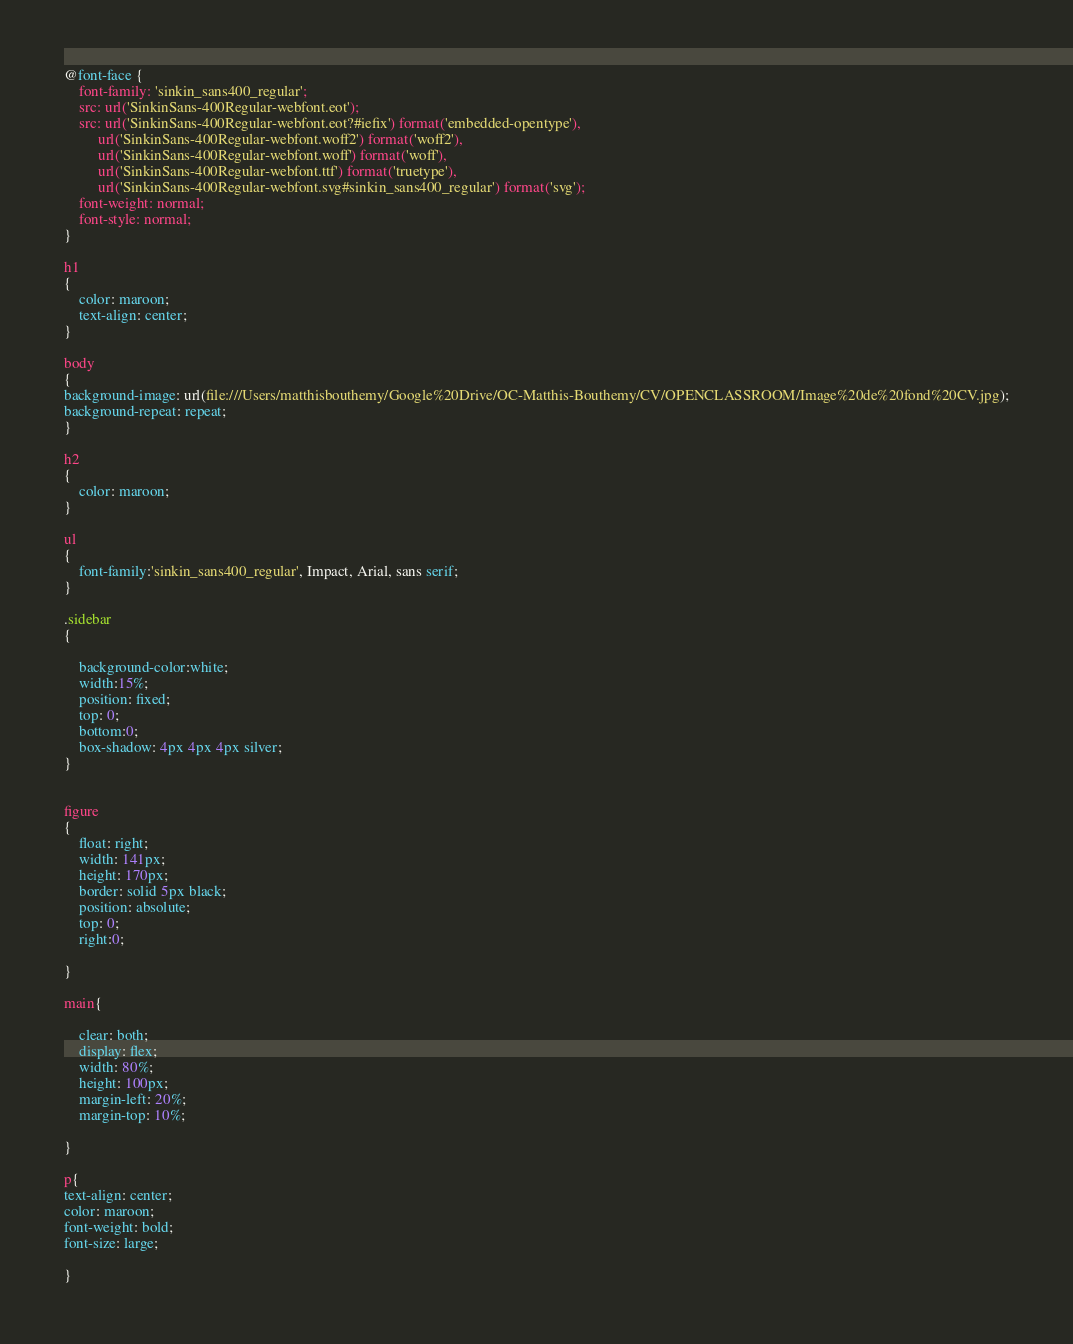<code> <loc_0><loc_0><loc_500><loc_500><_CSS_>@font-face {
    font-family: 'sinkin_sans400_regular';
    src: url('SinkinSans-400Regular-webfont.eot');
    src: url('SinkinSans-400Regular-webfont.eot?#iefix') format('embedded-opentype'),
         url('SinkinSans-400Regular-webfont.woff2') format('woff2'),
         url('SinkinSans-400Regular-webfont.woff') format('woff'),
         url('SinkinSans-400Regular-webfont.ttf') format('truetype'),
         url('SinkinSans-400Regular-webfont.svg#sinkin_sans400_regular') format('svg');
    font-weight: normal;
    font-style: normal;
}

h1
{
	color: maroon;
	text-align: center;
}

body
{
background-image: url(file:///Users/matthisbouthemy/Google%20Drive/OC-Matthis-Bouthemy/CV/OPENCLASSROOM/Image%20de%20fond%20CV.jpg);
background-repeat: repeat;
}

h2
{
	color: maroon;
}

ul
{
	font-family:'sinkin_sans400_regular', Impact, Arial, sans serif;
}

.sidebar
{

    background-color:white;
    width:15%;
    position: fixed;
    top: 0;
    bottom:0;
    box-shadow: 4px 4px 4px silver;
}


figure
{
    float: right;
    width: 141px;
    height: 170px;
    border: solid 5px black;
    position: absolute;
    top: 0;
    right:0;
    
}

main{

    clear: both;
    display: flex;
    width: 80%;
    height: 100px;
    margin-left: 20%;
    margin-top: 10%;
    
}

p{
text-align: center;
color: maroon;
font-weight: bold;
font-size: large;

}


</code> 